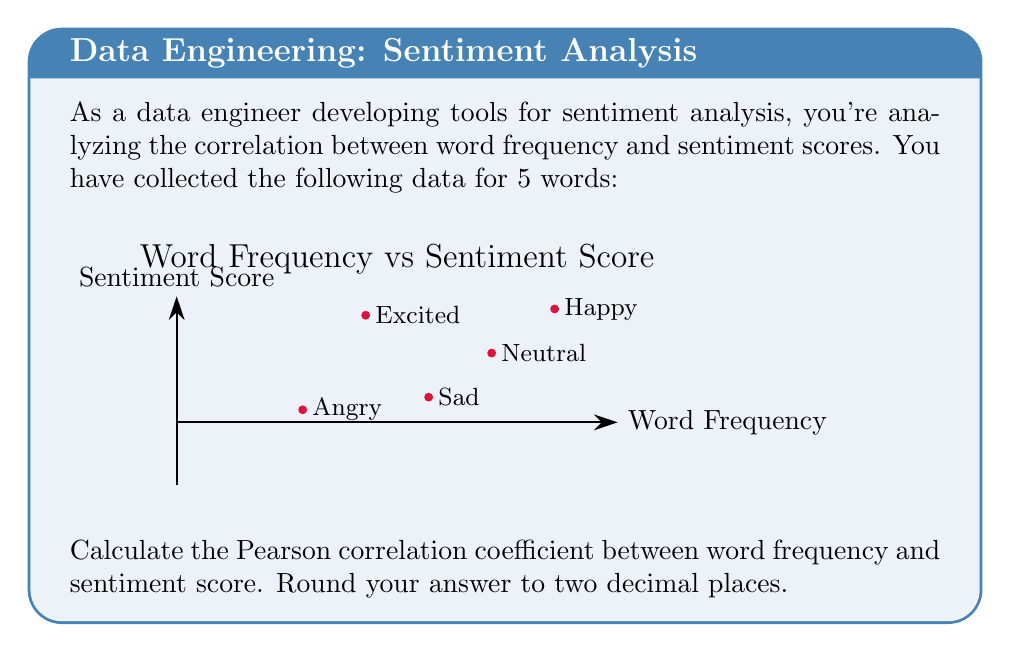What is the answer to this math problem? To calculate the Pearson correlation coefficient, we'll follow these steps:

1) First, let's recall the formula for Pearson correlation coefficient:

   $$r = \frac{\sum_{i=1}^{n} (x_i - \bar{x})(y_i - \bar{y})}{\sqrt{\sum_{i=1}^{n} (x_i - \bar{x})^2} \sqrt{\sum_{i=1}^{n} (y_i - \bar{y})^2}}$$

   Where $x_i$ are the frequency values and $y_i$ are the sentiment scores.

2) Calculate the means:
   $\bar{x} = \frac{120 + 80 + 60 + 40 + 100}{5} = 80$
   $\bar{y} = \frac{0.8 + (-0.6) + 0.7 + (-0.8) + 0.1}{5} = 0.04$

3) Calculate $(x_i - \bar{x})$ and $(y_i - \bar{y})$ for each point:
   
   | Word    | $x_i - \bar{x}$ | $y_i - \bar{y}$ | $(x_i - \bar{x})(y_i - \bar{y})$ | $(x_i - \bar{x})^2$ | $(y_i - \bar{y})^2$ |
   |---------|-----------------|-----------------|-----------------------------------|---------------------|---------------------|
   | Happy   | 40              | 0.76            | 30.4                              | 1600                | 0.5776              |
   | Sad     | 0               | -0.64           | 0                                 | 0                   | 0.4096              |
   | Excited | -20             | 0.66            | -13.2                             | 400                 | 0.4356              |
   | Angry   | -40             | -0.84           | 33.6                              | 1600                | 0.7056              |
   | Neutral | 20              | 0.06            | 1.2                               | 400                 | 0.0036              |

4) Sum up the columns:
   $\sum (x_i - \bar{x})(y_i - \bar{y}) = 52$
   $\sum (x_i - \bar{x})^2 = 4000$
   $\sum (y_i - \bar{y})^2 = 2.132$

5) Plug these values into the correlation formula:

   $$r = \frac{52}{\sqrt{4000} \sqrt{2.132}} = \frac{52}{92.2} \approx 0.5639$$

6) Rounding to two decimal places: 0.56
Answer: 0.56 